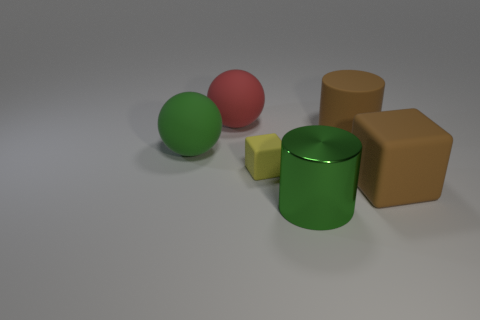How many things are rubber objects in front of the green ball or objects that are to the left of the green shiny cylinder?
Make the answer very short. 4. What number of brown rubber objects are there?
Make the answer very short. 2. Are there any brown matte blocks of the same size as the green metallic cylinder?
Your answer should be compact. Yes. Are the big red ball and the cylinder that is in front of the big brown cylinder made of the same material?
Keep it short and to the point. No. There is a cylinder in front of the small yellow rubber cube; what material is it?
Offer a terse response. Metal. What is the size of the yellow matte object?
Provide a succinct answer. Small. Do the cylinder that is in front of the large brown block and the brown rubber thing behind the big block have the same size?
Keep it short and to the point. Yes. Does the metal cylinder have the same size as the matte sphere to the left of the big red ball?
Make the answer very short. Yes. There is a brown matte object that is in front of the small rubber thing; are there any rubber cubes behind it?
Your answer should be compact. Yes. What is the shape of the large green thing that is to the right of the large red object?
Your answer should be compact. Cylinder. 